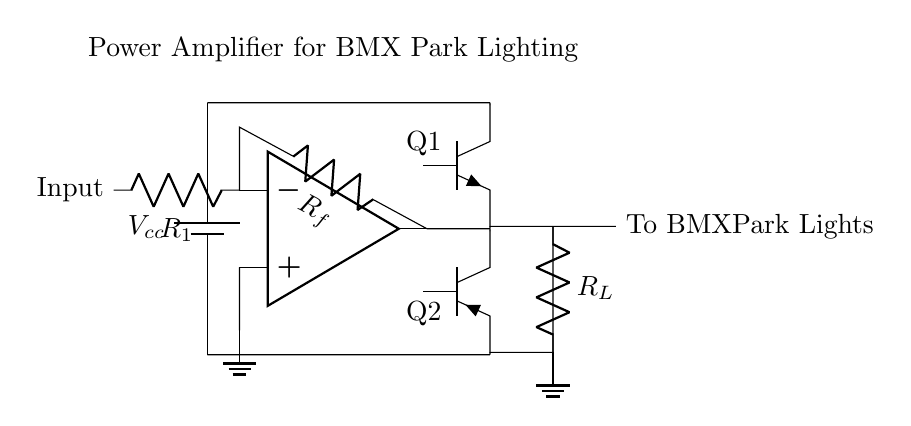What is the type of amplifier used in this circuit? The circuit diagram depicts an operational amplifier, denoted by the op amp symbol, which is specifically used here as a power amplifier for driving lights.
Answer: operational amplifier What does the resistor R1 connect to? Resistor R1 is connected to the input of the operational amplifier (op amp) and facilitates the input signal into the circuit.
Answer: input of the op amp What component represents the power supply in this circuit? The power supply is represented by a battery symbol in the diagram, denoted as Vcc, which provides the voltage necessary to power the amplifier.
Answer: Vcc What is the significance of Rf in this circuit? Resistor Rf is part of the feedback loop connecting the output of the op amp back to its inverting terminal, which helps determine the gain of the amplifier.
Answer: feedback loop How many transistors are present in the output stage? The output stage of the amplifier includes two transistors, one NPN (Q1) and one PNP (Q2), which are responsible for boosting the output current to drive the lights.
Answer: two transistors What is the load resistance associated with this circuit? The load resistance is indicated as R_L in the circuit diagram, which represents the combined resistance of the BMX park lights connected at the output.
Answer: R_L What is the purpose of the ground connection in this circuit? The ground connection provides a common reference point for the circuit, ensuring that the voltages throughout the circuit are measured relative to this zero voltage point.
Answer: common reference point 